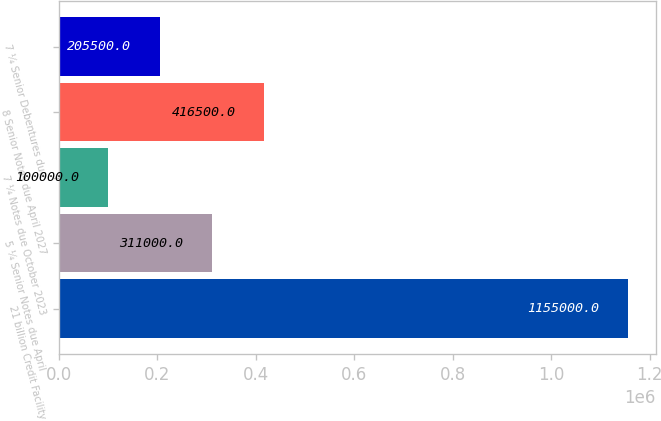<chart> <loc_0><loc_0><loc_500><loc_500><bar_chart><fcel>21 billion Credit Facility<fcel>5 ¼ Senior Notes due April<fcel>7 ¼ Notes due October 2023<fcel>8 Senior Notes due April 2027<fcel>7 ¼ Senior Debentures due<nl><fcel>1.155e+06<fcel>311000<fcel>100000<fcel>416500<fcel>205500<nl></chart> 